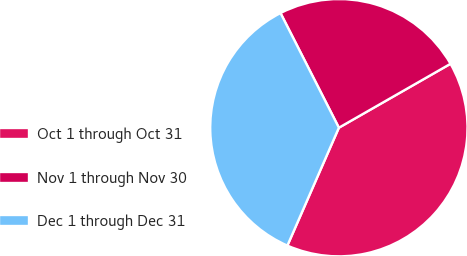Convert chart. <chart><loc_0><loc_0><loc_500><loc_500><pie_chart><fcel>Oct 1 through Oct 31<fcel>Nov 1 through Nov 30<fcel>Dec 1 through Dec 31<nl><fcel>39.83%<fcel>24.22%<fcel>35.95%<nl></chart> 